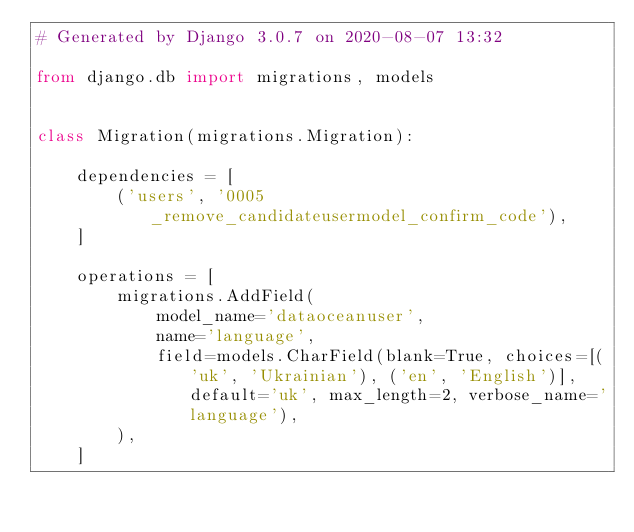<code> <loc_0><loc_0><loc_500><loc_500><_Python_># Generated by Django 3.0.7 on 2020-08-07 13:32

from django.db import migrations, models


class Migration(migrations.Migration):

    dependencies = [
        ('users', '0005_remove_candidateusermodel_confirm_code'),
    ]

    operations = [
        migrations.AddField(
            model_name='dataoceanuser',
            name='language',
            field=models.CharField(blank=True, choices=[('uk', 'Ukrainian'), ('en', 'English')], default='uk', max_length=2, verbose_name='language'),
        ),
    ]
</code> 